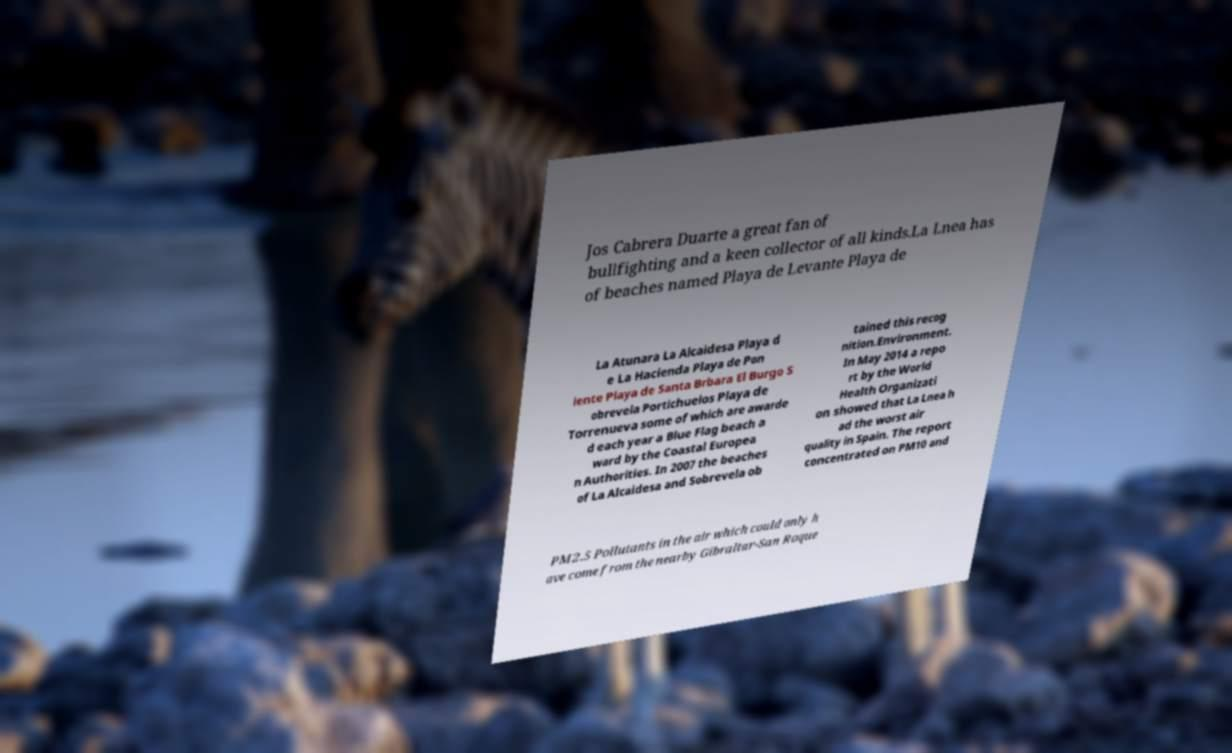Could you extract and type out the text from this image? Jos Cabrera Duarte a great fan of bullfighting and a keen collector of all kinds.La Lnea has of beaches named Playa de Levante Playa de La Atunara La Alcaidesa Playa d e La Hacienda Playa de Pon iente Playa de Santa Brbara El Burgo S obrevela Portichuelos Playa de Torrenueva some of which are awarde d each year a Blue Flag beach a ward by the Coastal Europea n Authorities. In 2007 the beaches of La Alcaidesa and Sobrevela ob tained this recog nition.Environment. In May 2014 a repo rt by the World Health Organizati on showed that La Lnea h ad the worst air quality in Spain. The report concentrated on PM10 and PM2.5 Pollutants in the air which could only h ave come from the nearby Gibraltar-San Roque 